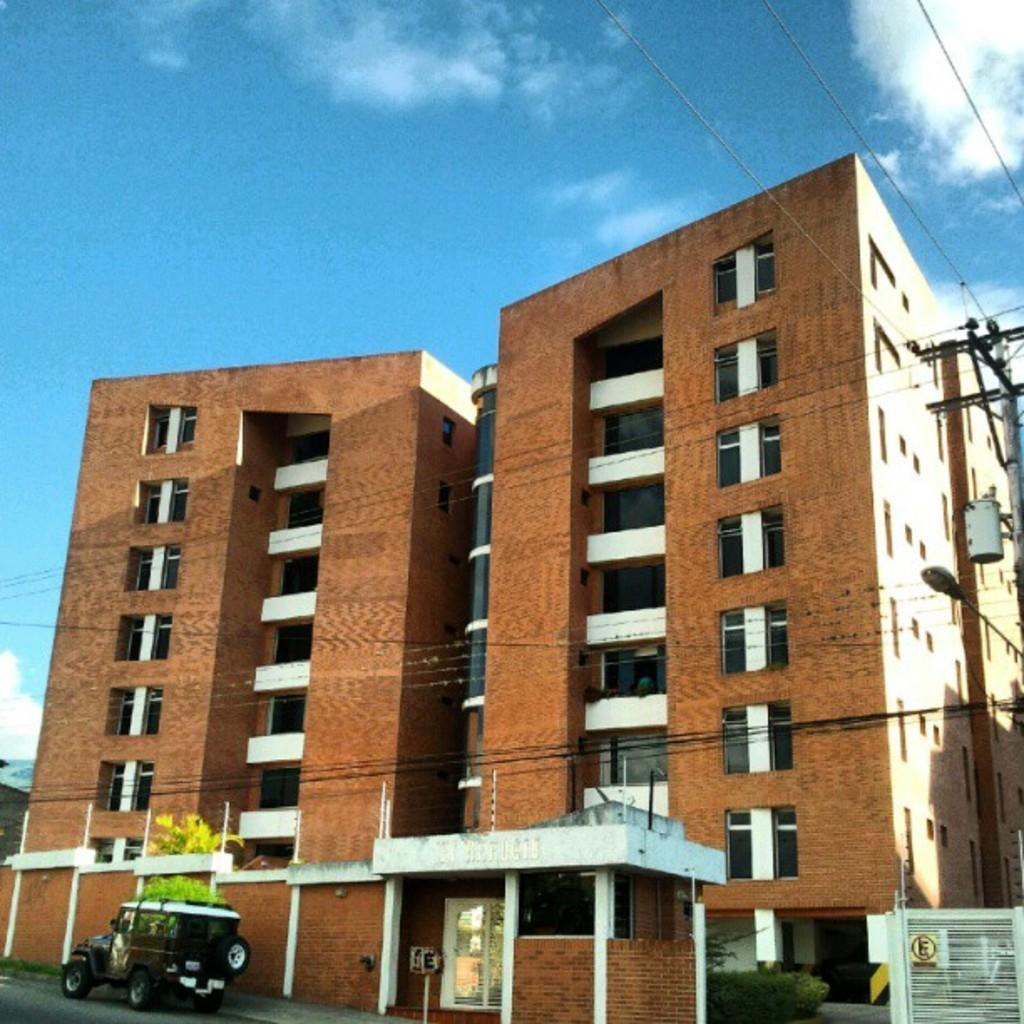What type of structures are visible in the image? There are buildings with windows in the image. What is located near the buildings? There is a tree and a vehicle near the buildings. What can be seen on the right side of the image? There is an electric pole with wires on the right side of the image. What is visible in the background of the image? The sky is visible in the background of the image. What type of fruit is hanging from the door in the image? There is no door or fruit present in the image. 